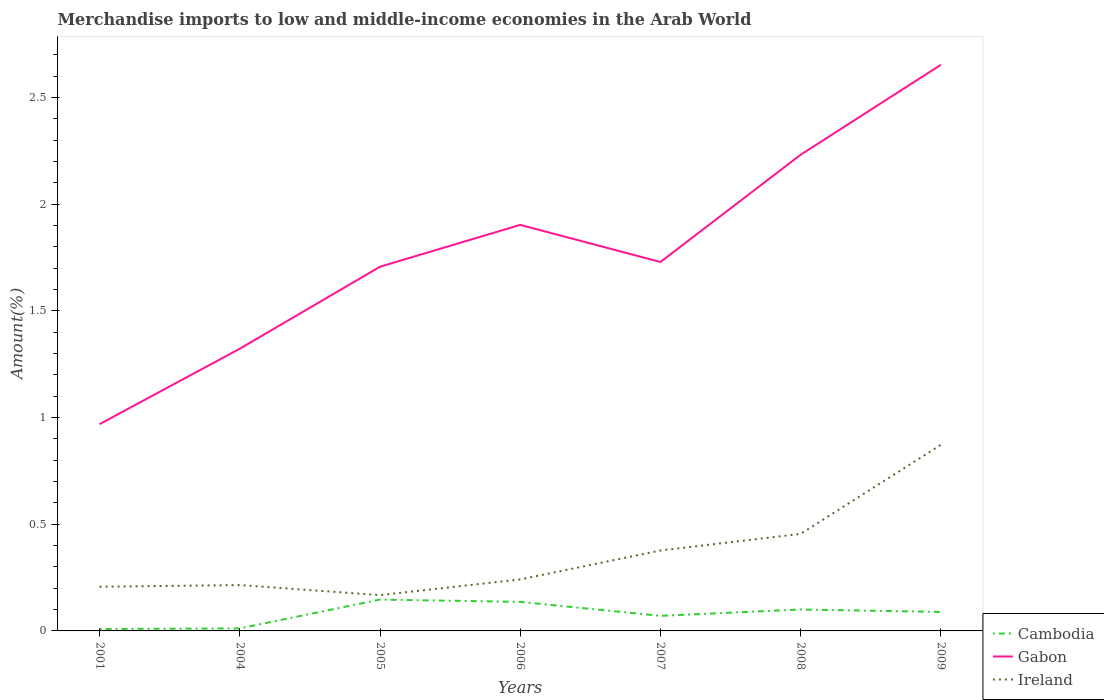How many different coloured lines are there?
Give a very brief answer. 3. Does the line corresponding to Gabon intersect with the line corresponding to Cambodia?
Ensure brevity in your answer.  No. Across all years, what is the maximum percentage of amount earned from merchandise imports in Cambodia?
Your response must be concise. 0.01. What is the total percentage of amount earned from merchandise imports in Ireland in the graph?
Your answer should be very brief. -0.5. What is the difference between the highest and the second highest percentage of amount earned from merchandise imports in Ireland?
Offer a terse response. 0.7. How many years are there in the graph?
Ensure brevity in your answer.  7. Are the values on the major ticks of Y-axis written in scientific E-notation?
Give a very brief answer. No. Does the graph contain grids?
Offer a very short reply. No. How are the legend labels stacked?
Your response must be concise. Vertical. What is the title of the graph?
Offer a very short reply. Merchandise imports to low and middle-income economies in the Arab World. What is the label or title of the Y-axis?
Your response must be concise. Amount(%). What is the Amount(%) in Cambodia in 2001?
Offer a terse response. 0.01. What is the Amount(%) of Gabon in 2001?
Offer a very short reply. 0.97. What is the Amount(%) of Ireland in 2001?
Your answer should be compact. 0.21. What is the Amount(%) of Cambodia in 2004?
Provide a succinct answer. 0.01. What is the Amount(%) in Gabon in 2004?
Give a very brief answer. 1.32. What is the Amount(%) in Ireland in 2004?
Your response must be concise. 0.21. What is the Amount(%) in Cambodia in 2005?
Offer a very short reply. 0.15. What is the Amount(%) in Gabon in 2005?
Your answer should be compact. 1.71. What is the Amount(%) in Ireland in 2005?
Provide a short and direct response. 0.17. What is the Amount(%) in Cambodia in 2006?
Your answer should be compact. 0.14. What is the Amount(%) in Gabon in 2006?
Your answer should be compact. 1.9. What is the Amount(%) in Ireland in 2006?
Keep it short and to the point. 0.24. What is the Amount(%) in Cambodia in 2007?
Offer a terse response. 0.07. What is the Amount(%) of Gabon in 2007?
Offer a terse response. 1.73. What is the Amount(%) in Ireland in 2007?
Offer a terse response. 0.38. What is the Amount(%) of Cambodia in 2008?
Keep it short and to the point. 0.1. What is the Amount(%) in Gabon in 2008?
Provide a short and direct response. 2.23. What is the Amount(%) in Ireland in 2008?
Offer a very short reply. 0.45. What is the Amount(%) of Cambodia in 2009?
Offer a terse response. 0.09. What is the Amount(%) of Gabon in 2009?
Ensure brevity in your answer.  2.65. What is the Amount(%) in Ireland in 2009?
Make the answer very short. 0.87. Across all years, what is the maximum Amount(%) of Cambodia?
Provide a succinct answer. 0.15. Across all years, what is the maximum Amount(%) of Gabon?
Offer a terse response. 2.65. Across all years, what is the maximum Amount(%) of Ireland?
Make the answer very short. 0.87. Across all years, what is the minimum Amount(%) of Cambodia?
Offer a very short reply. 0.01. Across all years, what is the minimum Amount(%) of Gabon?
Make the answer very short. 0.97. Across all years, what is the minimum Amount(%) of Ireland?
Your answer should be compact. 0.17. What is the total Amount(%) in Cambodia in the graph?
Your answer should be compact. 0.56. What is the total Amount(%) of Gabon in the graph?
Provide a short and direct response. 12.51. What is the total Amount(%) in Ireland in the graph?
Keep it short and to the point. 2.53. What is the difference between the Amount(%) of Cambodia in 2001 and that in 2004?
Offer a terse response. -0. What is the difference between the Amount(%) in Gabon in 2001 and that in 2004?
Your response must be concise. -0.35. What is the difference between the Amount(%) of Ireland in 2001 and that in 2004?
Ensure brevity in your answer.  -0.01. What is the difference between the Amount(%) in Cambodia in 2001 and that in 2005?
Provide a succinct answer. -0.14. What is the difference between the Amount(%) of Gabon in 2001 and that in 2005?
Your answer should be very brief. -0.74. What is the difference between the Amount(%) in Ireland in 2001 and that in 2005?
Your answer should be compact. 0.04. What is the difference between the Amount(%) in Cambodia in 2001 and that in 2006?
Provide a succinct answer. -0.13. What is the difference between the Amount(%) in Gabon in 2001 and that in 2006?
Offer a terse response. -0.93. What is the difference between the Amount(%) in Ireland in 2001 and that in 2006?
Your answer should be compact. -0.03. What is the difference between the Amount(%) of Cambodia in 2001 and that in 2007?
Ensure brevity in your answer.  -0.06. What is the difference between the Amount(%) in Gabon in 2001 and that in 2007?
Your answer should be compact. -0.76. What is the difference between the Amount(%) of Ireland in 2001 and that in 2007?
Provide a short and direct response. -0.17. What is the difference between the Amount(%) in Cambodia in 2001 and that in 2008?
Provide a succinct answer. -0.09. What is the difference between the Amount(%) of Gabon in 2001 and that in 2008?
Give a very brief answer. -1.26. What is the difference between the Amount(%) of Ireland in 2001 and that in 2008?
Provide a succinct answer. -0.25. What is the difference between the Amount(%) of Cambodia in 2001 and that in 2009?
Ensure brevity in your answer.  -0.08. What is the difference between the Amount(%) in Gabon in 2001 and that in 2009?
Provide a succinct answer. -1.68. What is the difference between the Amount(%) of Ireland in 2001 and that in 2009?
Your answer should be very brief. -0.67. What is the difference between the Amount(%) in Cambodia in 2004 and that in 2005?
Provide a short and direct response. -0.14. What is the difference between the Amount(%) in Gabon in 2004 and that in 2005?
Your response must be concise. -0.38. What is the difference between the Amount(%) in Ireland in 2004 and that in 2005?
Keep it short and to the point. 0.05. What is the difference between the Amount(%) of Cambodia in 2004 and that in 2006?
Provide a short and direct response. -0.12. What is the difference between the Amount(%) of Gabon in 2004 and that in 2006?
Offer a very short reply. -0.58. What is the difference between the Amount(%) in Ireland in 2004 and that in 2006?
Make the answer very short. -0.03. What is the difference between the Amount(%) of Cambodia in 2004 and that in 2007?
Offer a terse response. -0.06. What is the difference between the Amount(%) of Gabon in 2004 and that in 2007?
Offer a terse response. -0.41. What is the difference between the Amount(%) in Ireland in 2004 and that in 2007?
Ensure brevity in your answer.  -0.16. What is the difference between the Amount(%) of Cambodia in 2004 and that in 2008?
Provide a succinct answer. -0.09. What is the difference between the Amount(%) in Gabon in 2004 and that in 2008?
Keep it short and to the point. -0.91. What is the difference between the Amount(%) in Ireland in 2004 and that in 2008?
Your response must be concise. -0.24. What is the difference between the Amount(%) of Cambodia in 2004 and that in 2009?
Keep it short and to the point. -0.08. What is the difference between the Amount(%) in Gabon in 2004 and that in 2009?
Give a very brief answer. -1.33. What is the difference between the Amount(%) of Ireland in 2004 and that in 2009?
Your response must be concise. -0.66. What is the difference between the Amount(%) in Cambodia in 2005 and that in 2006?
Ensure brevity in your answer.  0.01. What is the difference between the Amount(%) in Gabon in 2005 and that in 2006?
Your answer should be compact. -0.2. What is the difference between the Amount(%) of Ireland in 2005 and that in 2006?
Give a very brief answer. -0.07. What is the difference between the Amount(%) of Cambodia in 2005 and that in 2007?
Make the answer very short. 0.08. What is the difference between the Amount(%) of Gabon in 2005 and that in 2007?
Your answer should be very brief. -0.02. What is the difference between the Amount(%) of Ireland in 2005 and that in 2007?
Your answer should be compact. -0.21. What is the difference between the Amount(%) in Cambodia in 2005 and that in 2008?
Give a very brief answer. 0.05. What is the difference between the Amount(%) of Gabon in 2005 and that in 2008?
Your answer should be very brief. -0.52. What is the difference between the Amount(%) in Ireland in 2005 and that in 2008?
Your answer should be very brief. -0.29. What is the difference between the Amount(%) of Cambodia in 2005 and that in 2009?
Provide a succinct answer. 0.06. What is the difference between the Amount(%) in Gabon in 2005 and that in 2009?
Offer a terse response. -0.95. What is the difference between the Amount(%) in Ireland in 2005 and that in 2009?
Keep it short and to the point. -0.7. What is the difference between the Amount(%) of Cambodia in 2006 and that in 2007?
Make the answer very short. 0.07. What is the difference between the Amount(%) in Gabon in 2006 and that in 2007?
Offer a terse response. 0.17. What is the difference between the Amount(%) of Ireland in 2006 and that in 2007?
Your answer should be very brief. -0.14. What is the difference between the Amount(%) in Cambodia in 2006 and that in 2008?
Provide a succinct answer. 0.04. What is the difference between the Amount(%) of Gabon in 2006 and that in 2008?
Your answer should be compact. -0.33. What is the difference between the Amount(%) of Ireland in 2006 and that in 2008?
Provide a succinct answer. -0.21. What is the difference between the Amount(%) of Cambodia in 2006 and that in 2009?
Provide a short and direct response. 0.05. What is the difference between the Amount(%) in Gabon in 2006 and that in 2009?
Ensure brevity in your answer.  -0.75. What is the difference between the Amount(%) of Ireland in 2006 and that in 2009?
Your answer should be very brief. -0.63. What is the difference between the Amount(%) of Cambodia in 2007 and that in 2008?
Your response must be concise. -0.03. What is the difference between the Amount(%) in Gabon in 2007 and that in 2008?
Keep it short and to the point. -0.5. What is the difference between the Amount(%) in Ireland in 2007 and that in 2008?
Provide a succinct answer. -0.08. What is the difference between the Amount(%) in Cambodia in 2007 and that in 2009?
Offer a very short reply. -0.02. What is the difference between the Amount(%) of Gabon in 2007 and that in 2009?
Offer a very short reply. -0.92. What is the difference between the Amount(%) in Ireland in 2007 and that in 2009?
Give a very brief answer. -0.5. What is the difference between the Amount(%) of Cambodia in 2008 and that in 2009?
Your answer should be very brief. 0.01. What is the difference between the Amount(%) of Gabon in 2008 and that in 2009?
Your response must be concise. -0.42. What is the difference between the Amount(%) in Ireland in 2008 and that in 2009?
Give a very brief answer. -0.42. What is the difference between the Amount(%) in Cambodia in 2001 and the Amount(%) in Gabon in 2004?
Your answer should be very brief. -1.31. What is the difference between the Amount(%) of Cambodia in 2001 and the Amount(%) of Ireland in 2004?
Your response must be concise. -0.21. What is the difference between the Amount(%) in Gabon in 2001 and the Amount(%) in Ireland in 2004?
Give a very brief answer. 0.75. What is the difference between the Amount(%) in Cambodia in 2001 and the Amount(%) in Gabon in 2005?
Keep it short and to the point. -1.7. What is the difference between the Amount(%) of Cambodia in 2001 and the Amount(%) of Ireland in 2005?
Your response must be concise. -0.16. What is the difference between the Amount(%) of Gabon in 2001 and the Amount(%) of Ireland in 2005?
Ensure brevity in your answer.  0.8. What is the difference between the Amount(%) of Cambodia in 2001 and the Amount(%) of Gabon in 2006?
Your answer should be compact. -1.89. What is the difference between the Amount(%) in Cambodia in 2001 and the Amount(%) in Ireland in 2006?
Give a very brief answer. -0.23. What is the difference between the Amount(%) in Gabon in 2001 and the Amount(%) in Ireland in 2006?
Make the answer very short. 0.73. What is the difference between the Amount(%) in Cambodia in 2001 and the Amount(%) in Gabon in 2007?
Keep it short and to the point. -1.72. What is the difference between the Amount(%) in Cambodia in 2001 and the Amount(%) in Ireland in 2007?
Your response must be concise. -0.37. What is the difference between the Amount(%) in Gabon in 2001 and the Amount(%) in Ireland in 2007?
Give a very brief answer. 0.59. What is the difference between the Amount(%) in Cambodia in 2001 and the Amount(%) in Gabon in 2008?
Provide a succinct answer. -2.22. What is the difference between the Amount(%) of Cambodia in 2001 and the Amount(%) of Ireland in 2008?
Keep it short and to the point. -0.45. What is the difference between the Amount(%) of Gabon in 2001 and the Amount(%) of Ireland in 2008?
Ensure brevity in your answer.  0.51. What is the difference between the Amount(%) in Cambodia in 2001 and the Amount(%) in Gabon in 2009?
Offer a very short reply. -2.64. What is the difference between the Amount(%) in Cambodia in 2001 and the Amount(%) in Ireland in 2009?
Ensure brevity in your answer.  -0.86. What is the difference between the Amount(%) in Gabon in 2001 and the Amount(%) in Ireland in 2009?
Your answer should be very brief. 0.1. What is the difference between the Amount(%) of Cambodia in 2004 and the Amount(%) of Gabon in 2005?
Provide a short and direct response. -1.69. What is the difference between the Amount(%) of Cambodia in 2004 and the Amount(%) of Ireland in 2005?
Your answer should be compact. -0.16. What is the difference between the Amount(%) in Gabon in 2004 and the Amount(%) in Ireland in 2005?
Give a very brief answer. 1.15. What is the difference between the Amount(%) in Cambodia in 2004 and the Amount(%) in Gabon in 2006?
Your answer should be very brief. -1.89. What is the difference between the Amount(%) in Cambodia in 2004 and the Amount(%) in Ireland in 2006?
Make the answer very short. -0.23. What is the difference between the Amount(%) in Gabon in 2004 and the Amount(%) in Ireland in 2006?
Make the answer very short. 1.08. What is the difference between the Amount(%) of Cambodia in 2004 and the Amount(%) of Gabon in 2007?
Provide a succinct answer. -1.72. What is the difference between the Amount(%) in Cambodia in 2004 and the Amount(%) in Ireland in 2007?
Keep it short and to the point. -0.37. What is the difference between the Amount(%) of Gabon in 2004 and the Amount(%) of Ireland in 2007?
Your answer should be compact. 0.95. What is the difference between the Amount(%) in Cambodia in 2004 and the Amount(%) in Gabon in 2008?
Keep it short and to the point. -2.22. What is the difference between the Amount(%) of Cambodia in 2004 and the Amount(%) of Ireland in 2008?
Your answer should be compact. -0.44. What is the difference between the Amount(%) in Gabon in 2004 and the Amount(%) in Ireland in 2008?
Ensure brevity in your answer.  0.87. What is the difference between the Amount(%) in Cambodia in 2004 and the Amount(%) in Gabon in 2009?
Offer a terse response. -2.64. What is the difference between the Amount(%) of Cambodia in 2004 and the Amount(%) of Ireland in 2009?
Give a very brief answer. -0.86. What is the difference between the Amount(%) of Gabon in 2004 and the Amount(%) of Ireland in 2009?
Provide a short and direct response. 0.45. What is the difference between the Amount(%) in Cambodia in 2005 and the Amount(%) in Gabon in 2006?
Give a very brief answer. -1.76. What is the difference between the Amount(%) in Cambodia in 2005 and the Amount(%) in Ireland in 2006?
Provide a short and direct response. -0.09. What is the difference between the Amount(%) of Gabon in 2005 and the Amount(%) of Ireland in 2006?
Ensure brevity in your answer.  1.47. What is the difference between the Amount(%) in Cambodia in 2005 and the Amount(%) in Gabon in 2007?
Provide a short and direct response. -1.58. What is the difference between the Amount(%) in Cambodia in 2005 and the Amount(%) in Ireland in 2007?
Your answer should be compact. -0.23. What is the difference between the Amount(%) in Gabon in 2005 and the Amount(%) in Ireland in 2007?
Keep it short and to the point. 1.33. What is the difference between the Amount(%) in Cambodia in 2005 and the Amount(%) in Gabon in 2008?
Ensure brevity in your answer.  -2.08. What is the difference between the Amount(%) in Cambodia in 2005 and the Amount(%) in Ireland in 2008?
Make the answer very short. -0.31. What is the difference between the Amount(%) in Gabon in 2005 and the Amount(%) in Ireland in 2008?
Your answer should be compact. 1.25. What is the difference between the Amount(%) of Cambodia in 2005 and the Amount(%) of Gabon in 2009?
Your response must be concise. -2.51. What is the difference between the Amount(%) in Cambodia in 2005 and the Amount(%) in Ireland in 2009?
Give a very brief answer. -0.73. What is the difference between the Amount(%) of Gabon in 2005 and the Amount(%) of Ireland in 2009?
Your response must be concise. 0.83. What is the difference between the Amount(%) in Cambodia in 2006 and the Amount(%) in Gabon in 2007?
Make the answer very short. -1.59. What is the difference between the Amount(%) in Cambodia in 2006 and the Amount(%) in Ireland in 2007?
Offer a terse response. -0.24. What is the difference between the Amount(%) of Gabon in 2006 and the Amount(%) of Ireland in 2007?
Make the answer very short. 1.53. What is the difference between the Amount(%) in Cambodia in 2006 and the Amount(%) in Gabon in 2008?
Provide a succinct answer. -2.1. What is the difference between the Amount(%) in Cambodia in 2006 and the Amount(%) in Ireland in 2008?
Your response must be concise. -0.32. What is the difference between the Amount(%) in Gabon in 2006 and the Amount(%) in Ireland in 2008?
Offer a very short reply. 1.45. What is the difference between the Amount(%) of Cambodia in 2006 and the Amount(%) of Gabon in 2009?
Give a very brief answer. -2.52. What is the difference between the Amount(%) of Cambodia in 2006 and the Amount(%) of Ireland in 2009?
Your answer should be very brief. -0.74. What is the difference between the Amount(%) of Gabon in 2006 and the Amount(%) of Ireland in 2009?
Make the answer very short. 1.03. What is the difference between the Amount(%) in Cambodia in 2007 and the Amount(%) in Gabon in 2008?
Offer a terse response. -2.16. What is the difference between the Amount(%) of Cambodia in 2007 and the Amount(%) of Ireland in 2008?
Your response must be concise. -0.38. What is the difference between the Amount(%) in Gabon in 2007 and the Amount(%) in Ireland in 2008?
Provide a short and direct response. 1.27. What is the difference between the Amount(%) in Cambodia in 2007 and the Amount(%) in Gabon in 2009?
Offer a terse response. -2.58. What is the difference between the Amount(%) of Cambodia in 2007 and the Amount(%) of Ireland in 2009?
Your answer should be compact. -0.8. What is the difference between the Amount(%) of Gabon in 2007 and the Amount(%) of Ireland in 2009?
Keep it short and to the point. 0.86. What is the difference between the Amount(%) of Cambodia in 2008 and the Amount(%) of Gabon in 2009?
Give a very brief answer. -2.55. What is the difference between the Amount(%) in Cambodia in 2008 and the Amount(%) in Ireland in 2009?
Keep it short and to the point. -0.77. What is the difference between the Amount(%) of Gabon in 2008 and the Amount(%) of Ireland in 2009?
Provide a short and direct response. 1.36. What is the average Amount(%) of Cambodia per year?
Provide a short and direct response. 0.08. What is the average Amount(%) in Gabon per year?
Offer a terse response. 1.79. What is the average Amount(%) in Ireland per year?
Provide a succinct answer. 0.36. In the year 2001, what is the difference between the Amount(%) in Cambodia and Amount(%) in Gabon?
Offer a very short reply. -0.96. In the year 2001, what is the difference between the Amount(%) of Cambodia and Amount(%) of Ireland?
Offer a terse response. -0.2. In the year 2001, what is the difference between the Amount(%) in Gabon and Amount(%) in Ireland?
Ensure brevity in your answer.  0.76. In the year 2004, what is the difference between the Amount(%) of Cambodia and Amount(%) of Gabon?
Provide a succinct answer. -1.31. In the year 2004, what is the difference between the Amount(%) in Cambodia and Amount(%) in Ireland?
Ensure brevity in your answer.  -0.2. In the year 2004, what is the difference between the Amount(%) of Gabon and Amount(%) of Ireland?
Provide a short and direct response. 1.11. In the year 2005, what is the difference between the Amount(%) in Cambodia and Amount(%) in Gabon?
Your answer should be compact. -1.56. In the year 2005, what is the difference between the Amount(%) in Cambodia and Amount(%) in Ireland?
Your response must be concise. -0.02. In the year 2005, what is the difference between the Amount(%) in Gabon and Amount(%) in Ireland?
Your answer should be very brief. 1.54. In the year 2006, what is the difference between the Amount(%) of Cambodia and Amount(%) of Gabon?
Your answer should be compact. -1.77. In the year 2006, what is the difference between the Amount(%) of Cambodia and Amount(%) of Ireland?
Make the answer very short. -0.11. In the year 2006, what is the difference between the Amount(%) in Gabon and Amount(%) in Ireland?
Offer a terse response. 1.66. In the year 2007, what is the difference between the Amount(%) in Cambodia and Amount(%) in Gabon?
Provide a succinct answer. -1.66. In the year 2007, what is the difference between the Amount(%) in Cambodia and Amount(%) in Ireland?
Make the answer very short. -0.31. In the year 2007, what is the difference between the Amount(%) of Gabon and Amount(%) of Ireland?
Your answer should be compact. 1.35. In the year 2008, what is the difference between the Amount(%) in Cambodia and Amount(%) in Gabon?
Ensure brevity in your answer.  -2.13. In the year 2008, what is the difference between the Amount(%) in Cambodia and Amount(%) in Ireland?
Provide a succinct answer. -0.35. In the year 2008, what is the difference between the Amount(%) of Gabon and Amount(%) of Ireland?
Make the answer very short. 1.78. In the year 2009, what is the difference between the Amount(%) of Cambodia and Amount(%) of Gabon?
Your answer should be very brief. -2.56. In the year 2009, what is the difference between the Amount(%) in Cambodia and Amount(%) in Ireland?
Offer a terse response. -0.78. In the year 2009, what is the difference between the Amount(%) of Gabon and Amount(%) of Ireland?
Offer a very short reply. 1.78. What is the ratio of the Amount(%) of Cambodia in 2001 to that in 2004?
Provide a short and direct response. 0.76. What is the ratio of the Amount(%) of Gabon in 2001 to that in 2004?
Your response must be concise. 0.73. What is the ratio of the Amount(%) in Ireland in 2001 to that in 2004?
Keep it short and to the point. 0.96. What is the ratio of the Amount(%) in Cambodia in 2001 to that in 2005?
Give a very brief answer. 0.06. What is the ratio of the Amount(%) of Gabon in 2001 to that in 2005?
Provide a short and direct response. 0.57. What is the ratio of the Amount(%) in Ireland in 2001 to that in 2005?
Ensure brevity in your answer.  1.23. What is the ratio of the Amount(%) in Cambodia in 2001 to that in 2006?
Offer a very short reply. 0.07. What is the ratio of the Amount(%) of Gabon in 2001 to that in 2006?
Your answer should be compact. 0.51. What is the ratio of the Amount(%) in Ireland in 2001 to that in 2006?
Offer a terse response. 0.86. What is the ratio of the Amount(%) in Cambodia in 2001 to that in 2007?
Your answer should be compact. 0.13. What is the ratio of the Amount(%) of Gabon in 2001 to that in 2007?
Your response must be concise. 0.56. What is the ratio of the Amount(%) of Ireland in 2001 to that in 2007?
Ensure brevity in your answer.  0.55. What is the ratio of the Amount(%) of Cambodia in 2001 to that in 2008?
Your answer should be very brief. 0.09. What is the ratio of the Amount(%) in Gabon in 2001 to that in 2008?
Offer a terse response. 0.43. What is the ratio of the Amount(%) of Ireland in 2001 to that in 2008?
Provide a succinct answer. 0.46. What is the ratio of the Amount(%) of Cambodia in 2001 to that in 2009?
Provide a succinct answer. 0.1. What is the ratio of the Amount(%) in Gabon in 2001 to that in 2009?
Give a very brief answer. 0.37. What is the ratio of the Amount(%) of Ireland in 2001 to that in 2009?
Your answer should be very brief. 0.24. What is the ratio of the Amount(%) of Cambodia in 2004 to that in 2005?
Offer a very short reply. 0.08. What is the ratio of the Amount(%) in Gabon in 2004 to that in 2005?
Keep it short and to the point. 0.77. What is the ratio of the Amount(%) in Ireland in 2004 to that in 2005?
Make the answer very short. 1.28. What is the ratio of the Amount(%) in Cambodia in 2004 to that in 2006?
Keep it short and to the point. 0.09. What is the ratio of the Amount(%) in Gabon in 2004 to that in 2006?
Your answer should be compact. 0.69. What is the ratio of the Amount(%) of Ireland in 2004 to that in 2006?
Your answer should be very brief. 0.89. What is the ratio of the Amount(%) in Cambodia in 2004 to that in 2007?
Give a very brief answer. 0.17. What is the ratio of the Amount(%) of Gabon in 2004 to that in 2007?
Provide a succinct answer. 0.77. What is the ratio of the Amount(%) in Ireland in 2004 to that in 2007?
Ensure brevity in your answer.  0.57. What is the ratio of the Amount(%) in Cambodia in 2004 to that in 2008?
Your response must be concise. 0.12. What is the ratio of the Amount(%) in Gabon in 2004 to that in 2008?
Provide a short and direct response. 0.59. What is the ratio of the Amount(%) in Ireland in 2004 to that in 2008?
Your response must be concise. 0.47. What is the ratio of the Amount(%) in Cambodia in 2004 to that in 2009?
Offer a very short reply. 0.13. What is the ratio of the Amount(%) of Gabon in 2004 to that in 2009?
Ensure brevity in your answer.  0.5. What is the ratio of the Amount(%) of Ireland in 2004 to that in 2009?
Provide a succinct answer. 0.25. What is the ratio of the Amount(%) of Cambodia in 2005 to that in 2006?
Keep it short and to the point. 1.08. What is the ratio of the Amount(%) in Gabon in 2005 to that in 2006?
Keep it short and to the point. 0.9. What is the ratio of the Amount(%) in Ireland in 2005 to that in 2006?
Your response must be concise. 0.69. What is the ratio of the Amount(%) in Cambodia in 2005 to that in 2007?
Make the answer very short. 2.08. What is the ratio of the Amount(%) of Gabon in 2005 to that in 2007?
Give a very brief answer. 0.99. What is the ratio of the Amount(%) in Ireland in 2005 to that in 2007?
Give a very brief answer. 0.44. What is the ratio of the Amount(%) of Cambodia in 2005 to that in 2008?
Make the answer very short. 1.46. What is the ratio of the Amount(%) of Gabon in 2005 to that in 2008?
Offer a terse response. 0.76. What is the ratio of the Amount(%) of Ireland in 2005 to that in 2008?
Provide a short and direct response. 0.37. What is the ratio of the Amount(%) in Cambodia in 2005 to that in 2009?
Your answer should be compact. 1.65. What is the ratio of the Amount(%) of Gabon in 2005 to that in 2009?
Your response must be concise. 0.64. What is the ratio of the Amount(%) in Ireland in 2005 to that in 2009?
Give a very brief answer. 0.19. What is the ratio of the Amount(%) in Cambodia in 2006 to that in 2007?
Your answer should be very brief. 1.93. What is the ratio of the Amount(%) in Gabon in 2006 to that in 2007?
Offer a very short reply. 1.1. What is the ratio of the Amount(%) of Ireland in 2006 to that in 2007?
Your response must be concise. 0.64. What is the ratio of the Amount(%) of Cambodia in 2006 to that in 2008?
Ensure brevity in your answer.  1.36. What is the ratio of the Amount(%) of Gabon in 2006 to that in 2008?
Make the answer very short. 0.85. What is the ratio of the Amount(%) in Ireland in 2006 to that in 2008?
Provide a short and direct response. 0.53. What is the ratio of the Amount(%) of Cambodia in 2006 to that in 2009?
Keep it short and to the point. 1.53. What is the ratio of the Amount(%) in Gabon in 2006 to that in 2009?
Make the answer very short. 0.72. What is the ratio of the Amount(%) in Ireland in 2006 to that in 2009?
Your answer should be very brief. 0.28. What is the ratio of the Amount(%) in Cambodia in 2007 to that in 2008?
Ensure brevity in your answer.  0.7. What is the ratio of the Amount(%) of Gabon in 2007 to that in 2008?
Make the answer very short. 0.77. What is the ratio of the Amount(%) in Ireland in 2007 to that in 2008?
Offer a terse response. 0.83. What is the ratio of the Amount(%) in Cambodia in 2007 to that in 2009?
Give a very brief answer. 0.79. What is the ratio of the Amount(%) of Gabon in 2007 to that in 2009?
Keep it short and to the point. 0.65. What is the ratio of the Amount(%) in Ireland in 2007 to that in 2009?
Your answer should be compact. 0.43. What is the ratio of the Amount(%) of Cambodia in 2008 to that in 2009?
Give a very brief answer. 1.13. What is the ratio of the Amount(%) of Gabon in 2008 to that in 2009?
Keep it short and to the point. 0.84. What is the ratio of the Amount(%) in Ireland in 2008 to that in 2009?
Offer a terse response. 0.52. What is the difference between the highest and the second highest Amount(%) in Cambodia?
Offer a terse response. 0.01. What is the difference between the highest and the second highest Amount(%) of Gabon?
Give a very brief answer. 0.42. What is the difference between the highest and the second highest Amount(%) in Ireland?
Your answer should be very brief. 0.42. What is the difference between the highest and the lowest Amount(%) in Cambodia?
Provide a short and direct response. 0.14. What is the difference between the highest and the lowest Amount(%) of Gabon?
Make the answer very short. 1.68. What is the difference between the highest and the lowest Amount(%) in Ireland?
Provide a succinct answer. 0.7. 